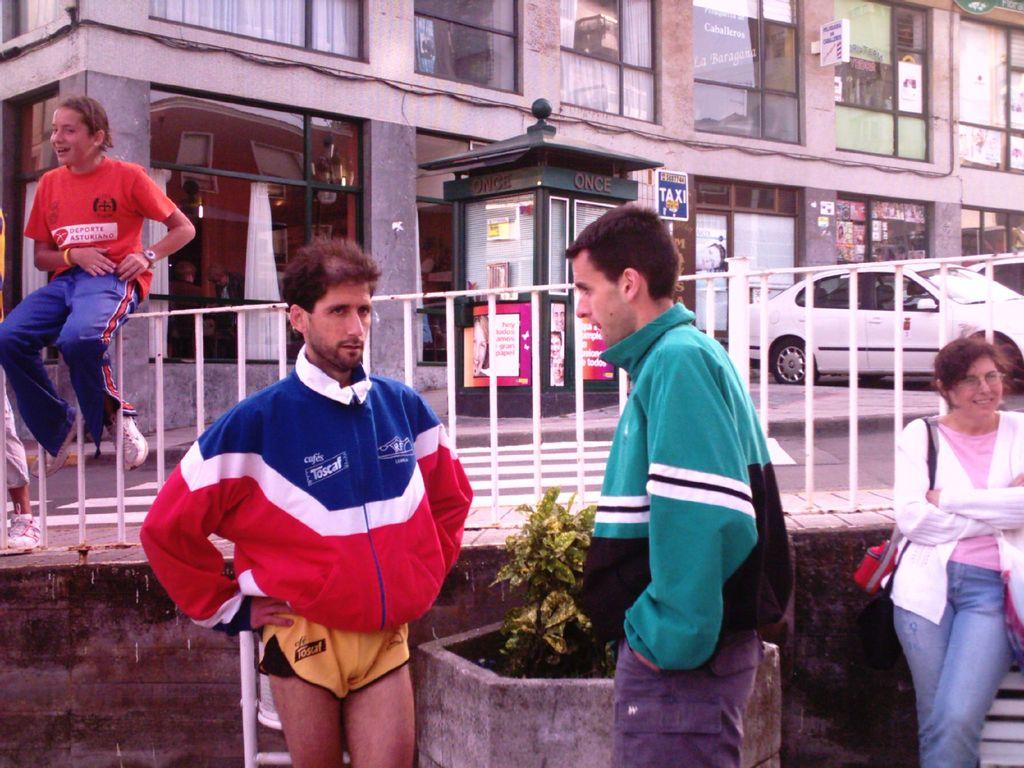What word is at the top of the dark green kiosk?
Provide a short and direct response. Once. 